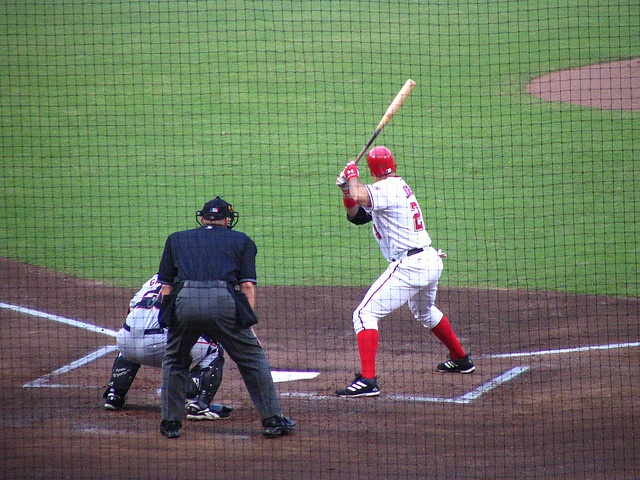Describe the objects in this image and their specific colors. I can see people in teal, black, navy, gray, and darkblue tones, people in teal, lavender, gray, and black tones, people in teal, black, navy, lavender, and darkgray tones, and baseball bat in teal, white, tan, and darkgray tones in this image. 